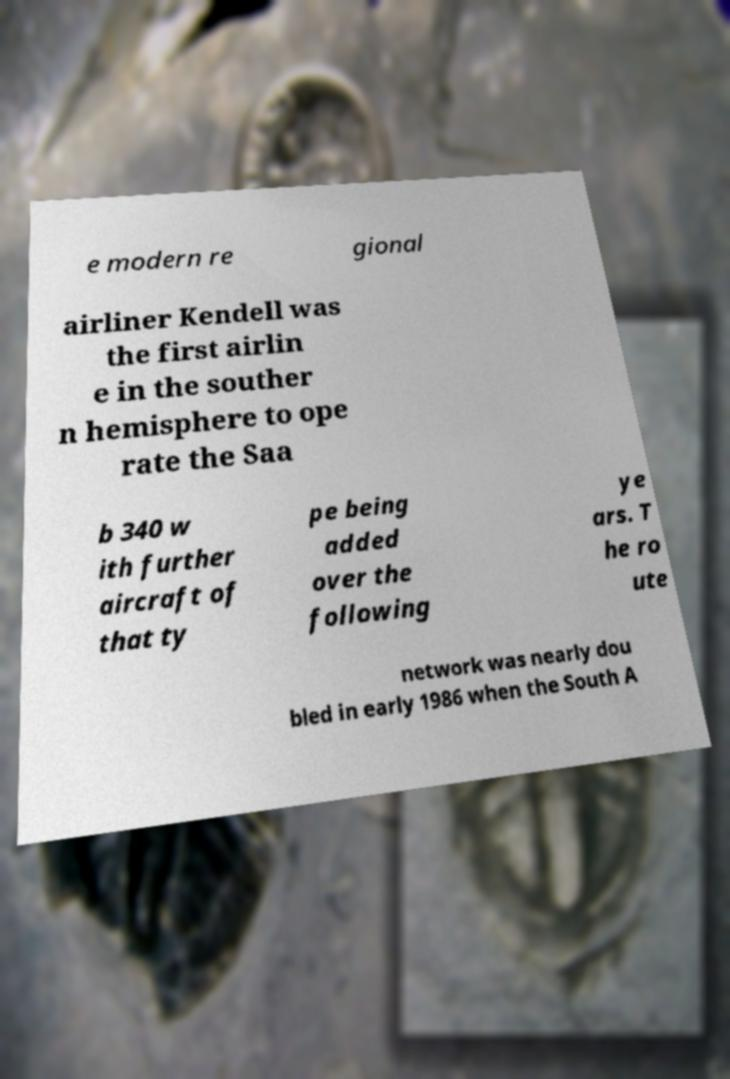For documentation purposes, I need the text within this image transcribed. Could you provide that? e modern re gional airliner Kendell was the first airlin e in the souther n hemisphere to ope rate the Saa b 340 w ith further aircraft of that ty pe being added over the following ye ars. T he ro ute network was nearly dou bled in early 1986 when the South A 